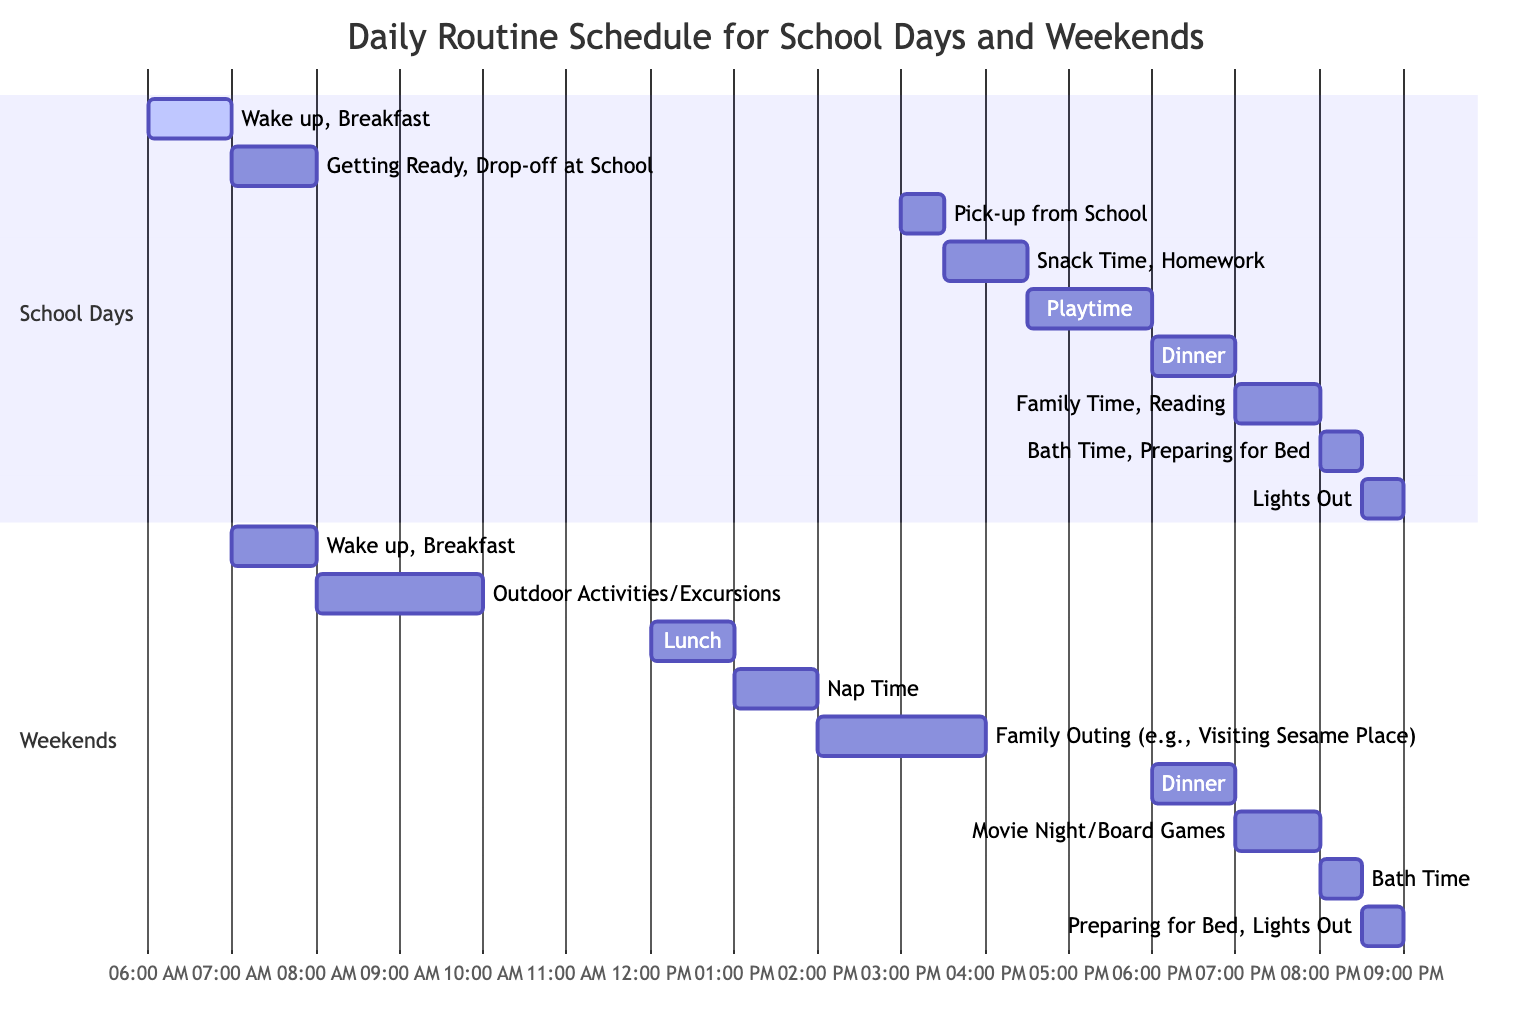What time do the children wake up on school days? The diagram shows that on school days, the activity "Wake up, Breakfast" starts at 06:00. Therefore, the wake-up time is exactly at this hour.
Answer: 06:00 What is the duration of playtime after school? According to the diagram, "Playtime" lasts for 90 minutes after "Snack Time, Homework," which begins at 16:30 and ends at 18:00. Therefore, the duration of playtime is 90 minutes.
Answer: 90m What activities are scheduled immediately after lunch on weekends? The diagram indicates that after "Lunch," scheduled from 12:00 to 1:00 PM, "Nap Time" starts at 13:00. These two activities are directly consecutive.
Answer: Nap Time How many total hours are dedicated to family activities on the weekend? The weekend section lists two family activities: "Family Outing (e.g., Visiting Sesame Place)" for 2 hours and "Movie Night/Board Games" for 1 hour. Adding these together gives a total of 3 hours for family activities.
Answer: 3h What time does bath time occur on both school days and weekends? The diagram shows "Bath Time, Preparing for Bed" scheduled at 20:00 on school days and "Bath Time" at 20:00 on weekends as well. Therefore, bath time occurs at the same hour for both.
Answer: 20:00 Which activity has the longest time block during school days? By examining the time blocks, "Playtime," which lasts for 90 minutes, is the longest duration among all activities scheduled on school days.
Answer: Playtime What is the last activity of the day on weekends? The diagram reveals that "Preparing for Bed, Lights Out" is the final scheduled activity of the day on weekends, set to start at 20:30.
Answer: Preparing for Bed, Lights Out What are the activities listed from 18:00 to 19:00 on school days? Looking closely at the diagram, from 18:00 to 19:00, the activity is "Dinner," which occupies the entire hour without any other activities overlapping.
Answer: Dinner 